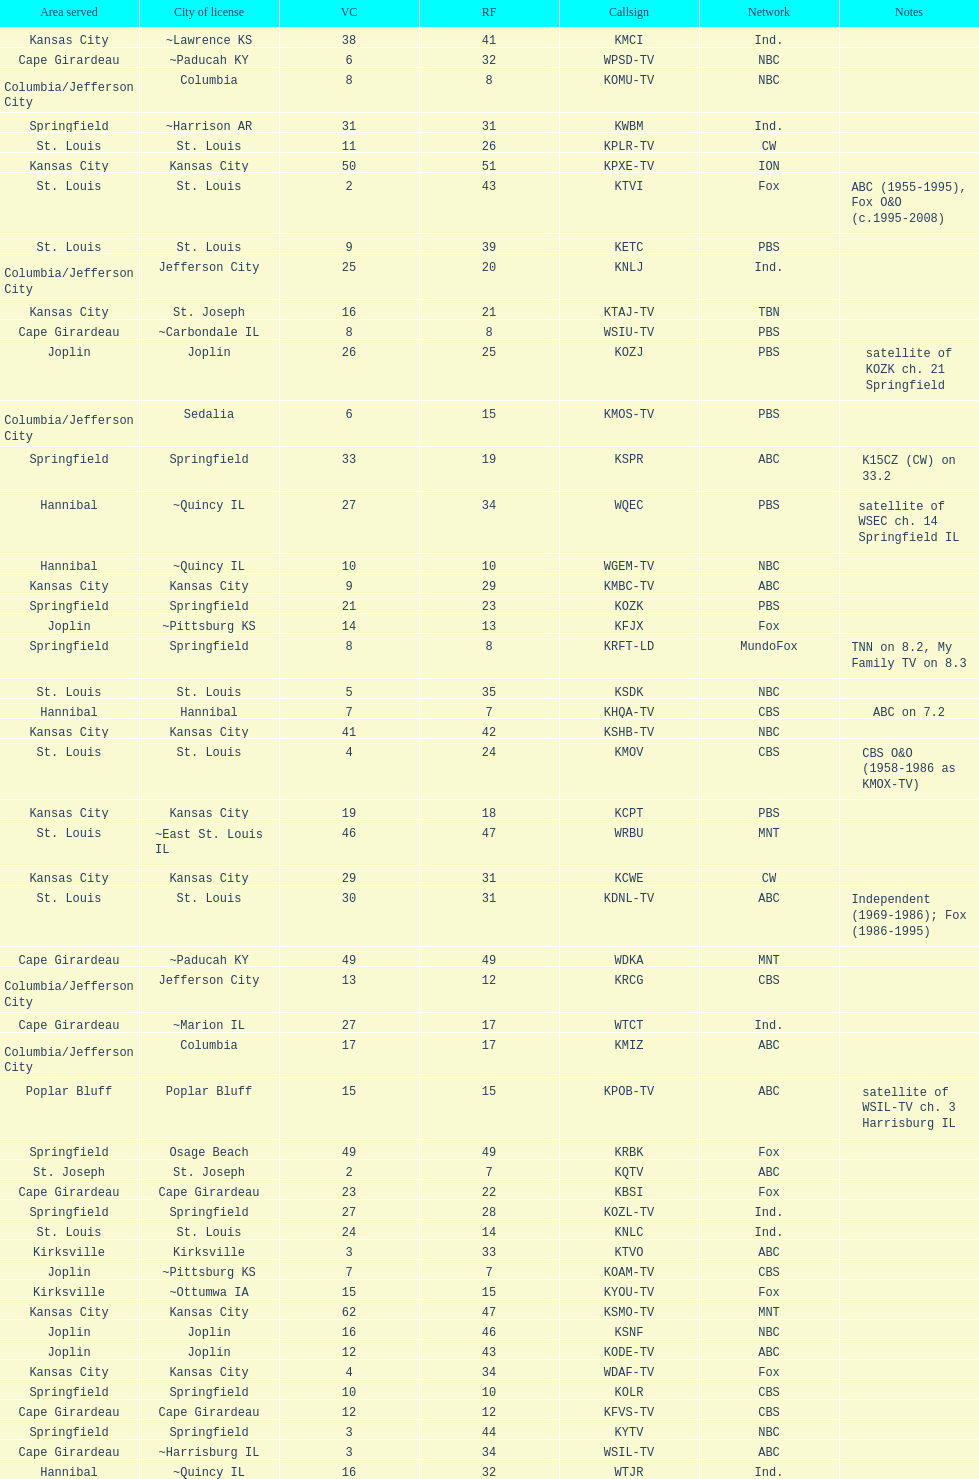How many are on the cbs network? 7. 